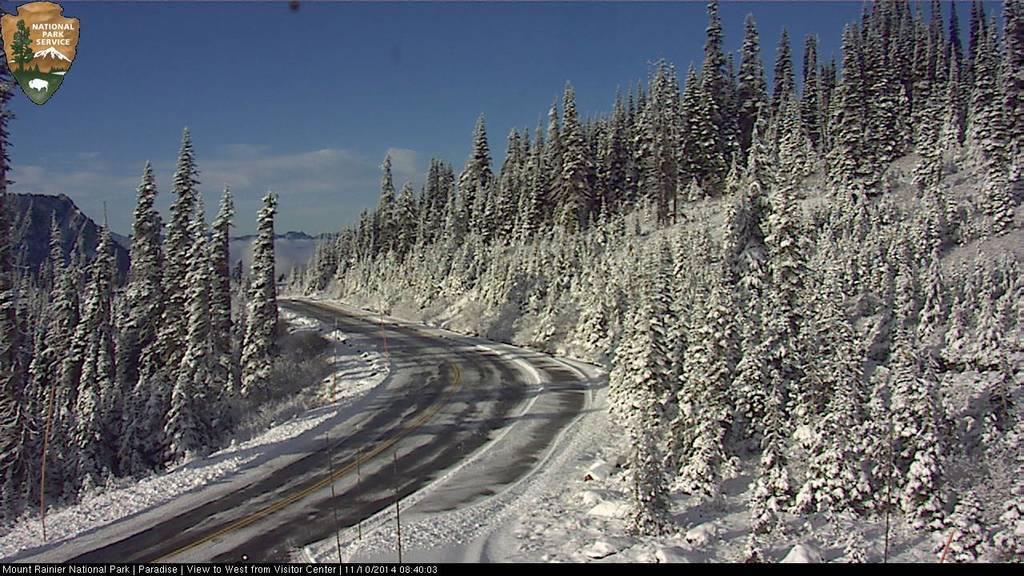Can you describe this image briefly? In this image on the right side and left side there are some trees, and in the center there is a walkway and the trees are covered with snow and in the background there are some mountains. At the top of the image there is sky. 